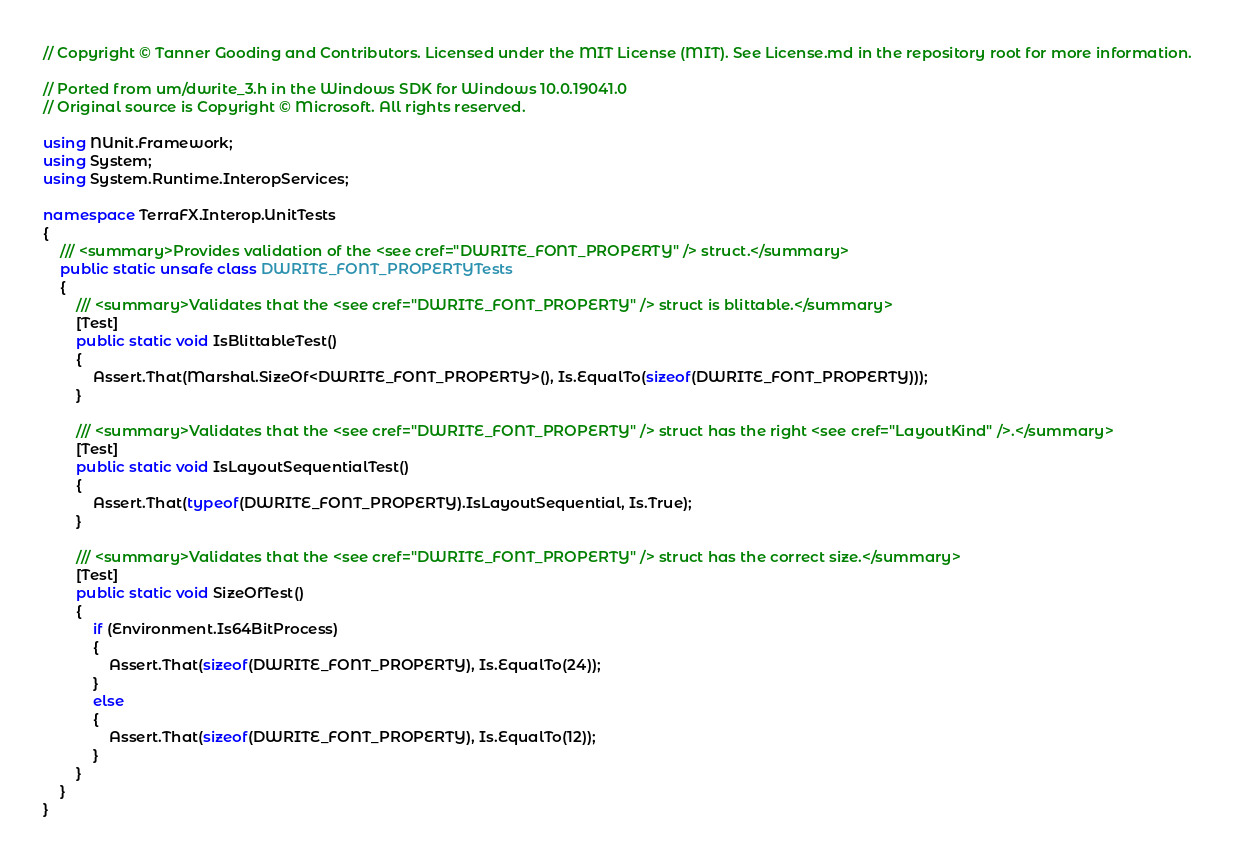<code> <loc_0><loc_0><loc_500><loc_500><_C#_>// Copyright © Tanner Gooding and Contributors. Licensed under the MIT License (MIT). See License.md in the repository root for more information.

// Ported from um/dwrite_3.h in the Windows SDK for Windows 10.0.19041.0
// Original source is Copyright © Microsoft. All rights reserved.

using NUnit.Framework;
using System;
using System.Runtime.InteropServices;

namespace TerraFX.Interop.UnitTests
{
    /// <summary>Provides validation of the <see cref="DWRITE_FONT_PROPERTY" /> struct.</summary>
    public static unsafe class DWRITE_FONT_PROPERTYTests
    {
        /// <summary>Validates that the <see cref="DWRITE_FONT_PROPERTY" /> struct is blittable.</summary>
        [Test]
        public static void IsBlittableTest()
        {
            Assert.That(Marshal.SizeOf<DWRITE_FONT_PROPERTY>(), Is.EqualTo(sizeof(DWRITE_FONT_PROPERTY)));
        }

        /// <summary>Validates that the <see cref="DWRITE_FONT_PROPERTY" /> struct has the right <see cref="LayoutKind" />.</summary>
        [Test]
        public static void IsLayoutSequentialTest()
        {
            Assert.That(typeof(DWRITE_FONT_PROPERTY).IsLayoutSequential, Is.True);
        }

        /// <summary>Validates that the <see cref="DWRITE_FONT_PROPERTY" /> struct has the correct size.</summary>
        [Test]
        public static void SizeOfTest()
        {
            if (Environment.Is64BitProcess)
            {
                Assert.That(sizeof(DWRITE_FONT_PROPERTY), Is.EqualTo(24));
            }
            else
            {
                Assert.That(sizeof(DWRITE_FONT_PROPERTY), Is.EqualTo(12));
            }
        }
    }
}
</code> 